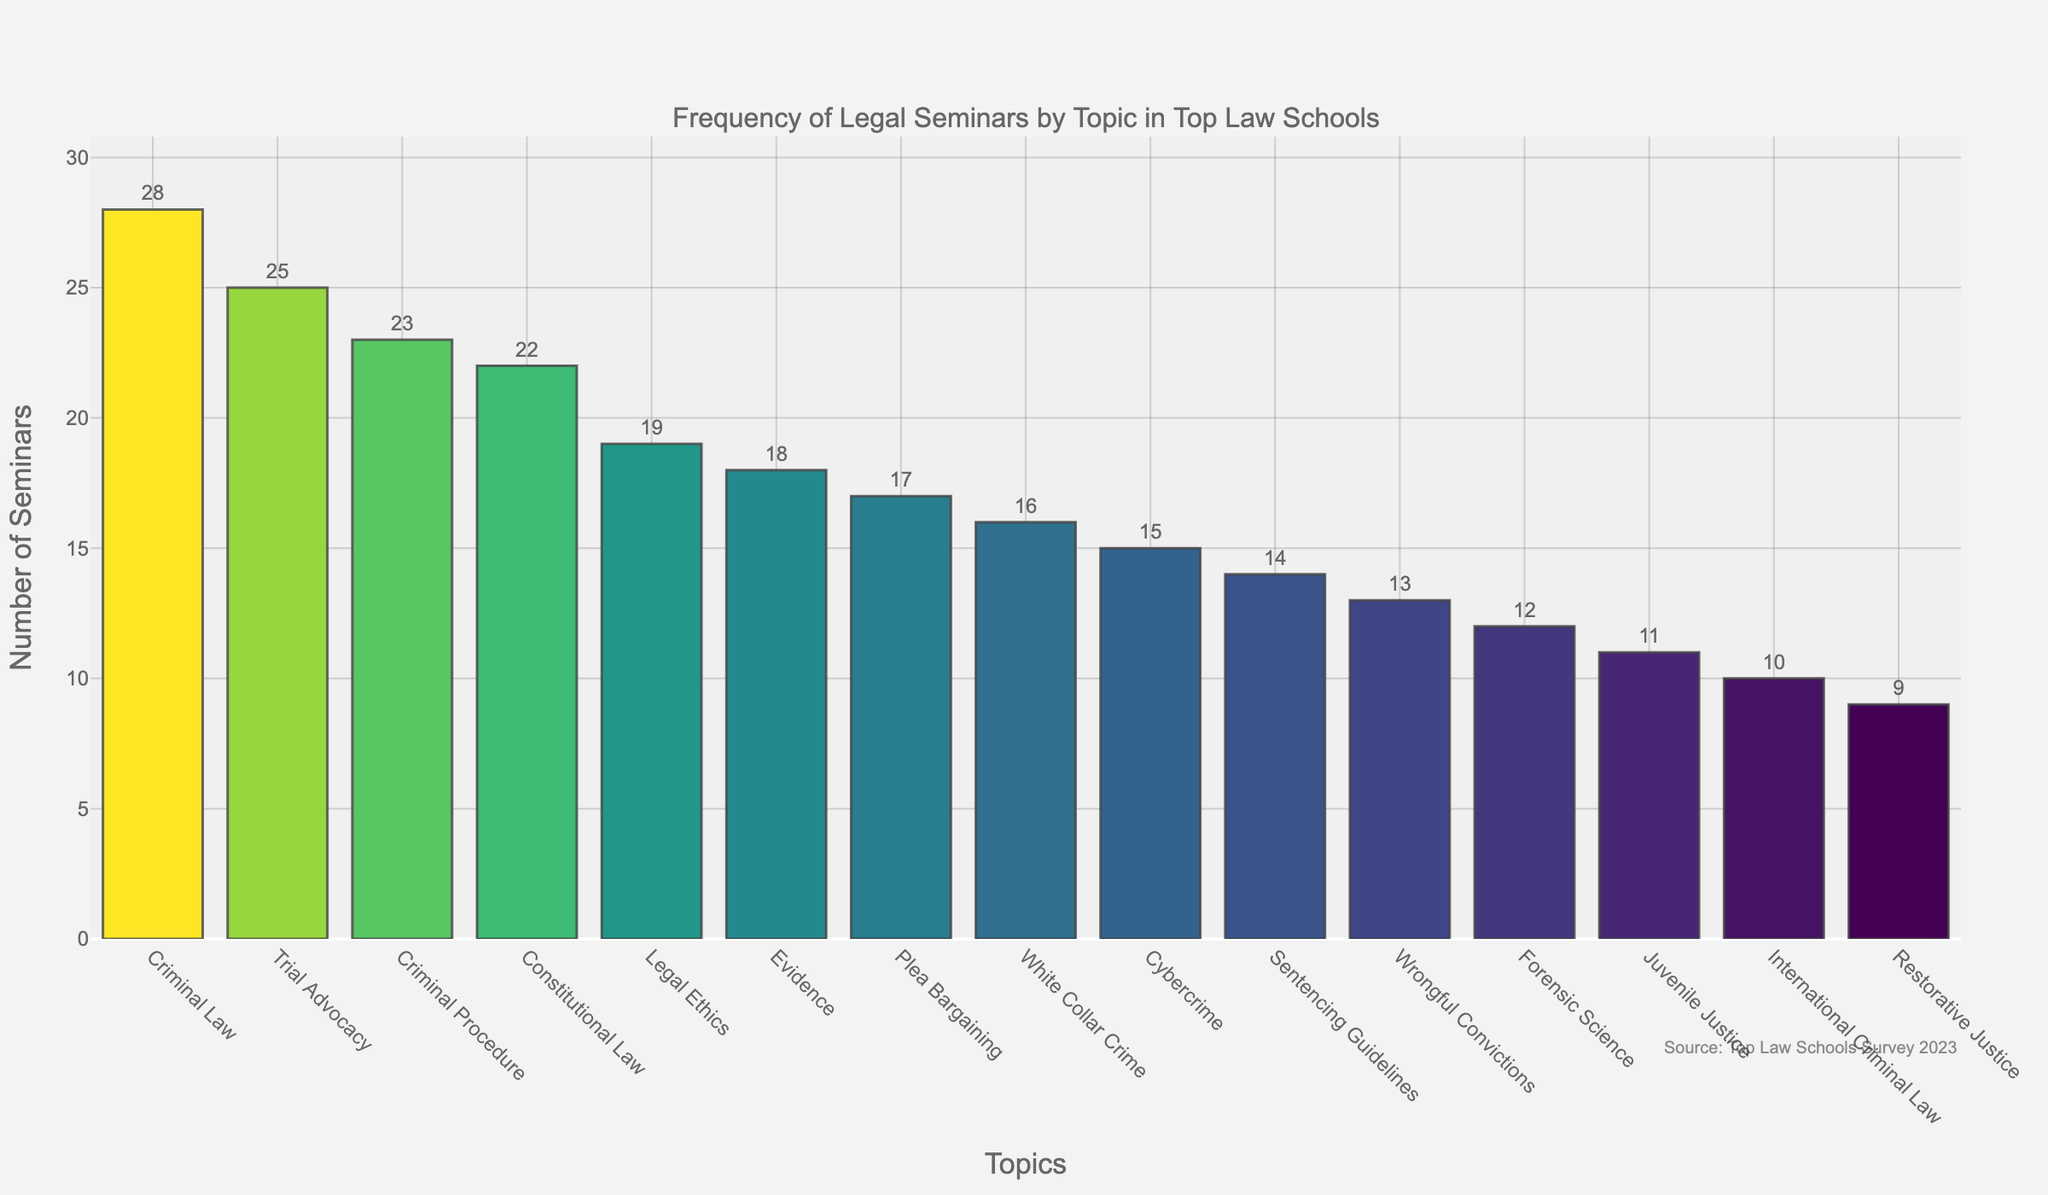What topic had the highest number of seminars? From the bar chart, the topic with the tallest bar represents the highest number of seminars. "Criminal Law" has the tallest bar.
Answer: Criminal Law What is the combined number of seminars for Trial Advocacy and Criminal Procedure? Locate the bars for "Trial Advocacy" and "Criminal Procedure." "Trial Advocacy" has 25 seminars and "Criminal Procedure" has 23. Adding them together: 25 + 23 = 48.
Answer: 48 Which topic had fewer seminars: Plea Bargaining or White Collar Crime? Compare the heights of the bars for "Plea Bargaining" and "White Collar Crime." "Plea Bargaining" has 17 seminars and "White Collar Crime" has 16.
Answer: White Collar Crime What is the range of the number of seminars across all topics? Identify the topics with the maximum and minimum number of seminars. "Criminal Law" has the maximum (28 seminars) and "Restorative Justice" has the minimum (9 seminars). The range is 28 - 9 = 19.
Answer: 19 How many more seminars are held for Criminal Law compared to Cybercrime? Find the values for "Criminal Law" and "Cybercrime." "Criminal Law" has 28 seminars, and "Cybercrime" has 15. Subtract the smaller number from the larger number: 28 - 15 = 13.
Answer: 13 Does Evidence have more or fewer seminars than Legal Ethics? Compare the bars for "Evidence" and "Legal Ethics." "Evidence" has 18 seminars, and "Legal Ethics" has 19 seminars.
Answer: Fewer Which topic had the least number of seminars, and how many were there? The shortest bar represents the least number of seminars. "Restorative Justice" has the shortest bar with 9 seminars.
Answer: Restorative Justice, 9 What is the sum of seminars for all topics with fewer than 15 seminars? Identify the topics with fewer than 15 seminars: "Juvenile Justice" (11), "Wrongful Convictions" (13), "International Criminal Law" (10), and "Restorative Justice" (9). Sum these values: 11 + 13 + 10 + 9 = 43.
Answer: 43 